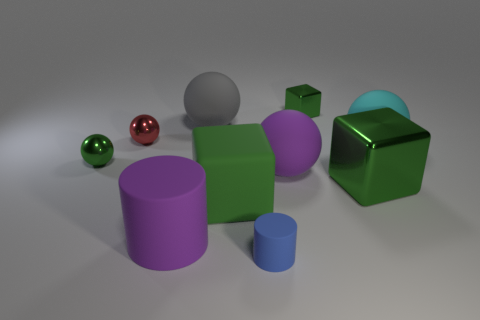Subtract all purple balls. How many balls are left? 4 Subtract all tiny red spheres. How many spheres are left? 4 Subtract all yellow balls. Subtract all blue cylinders. How many balls are left? 5 Subtract all blocks. How many objects are left? 7 Subtract 0 brown cylinders. How many objects are left? 10 Subtract all small cyan cylinders. Subtract all green spheres. How many objects are left? 9 Add 4 rubber things. How many rubber things are left? 10 Add 1 green rubber blocks. How many green rubber blocks exist? 2 